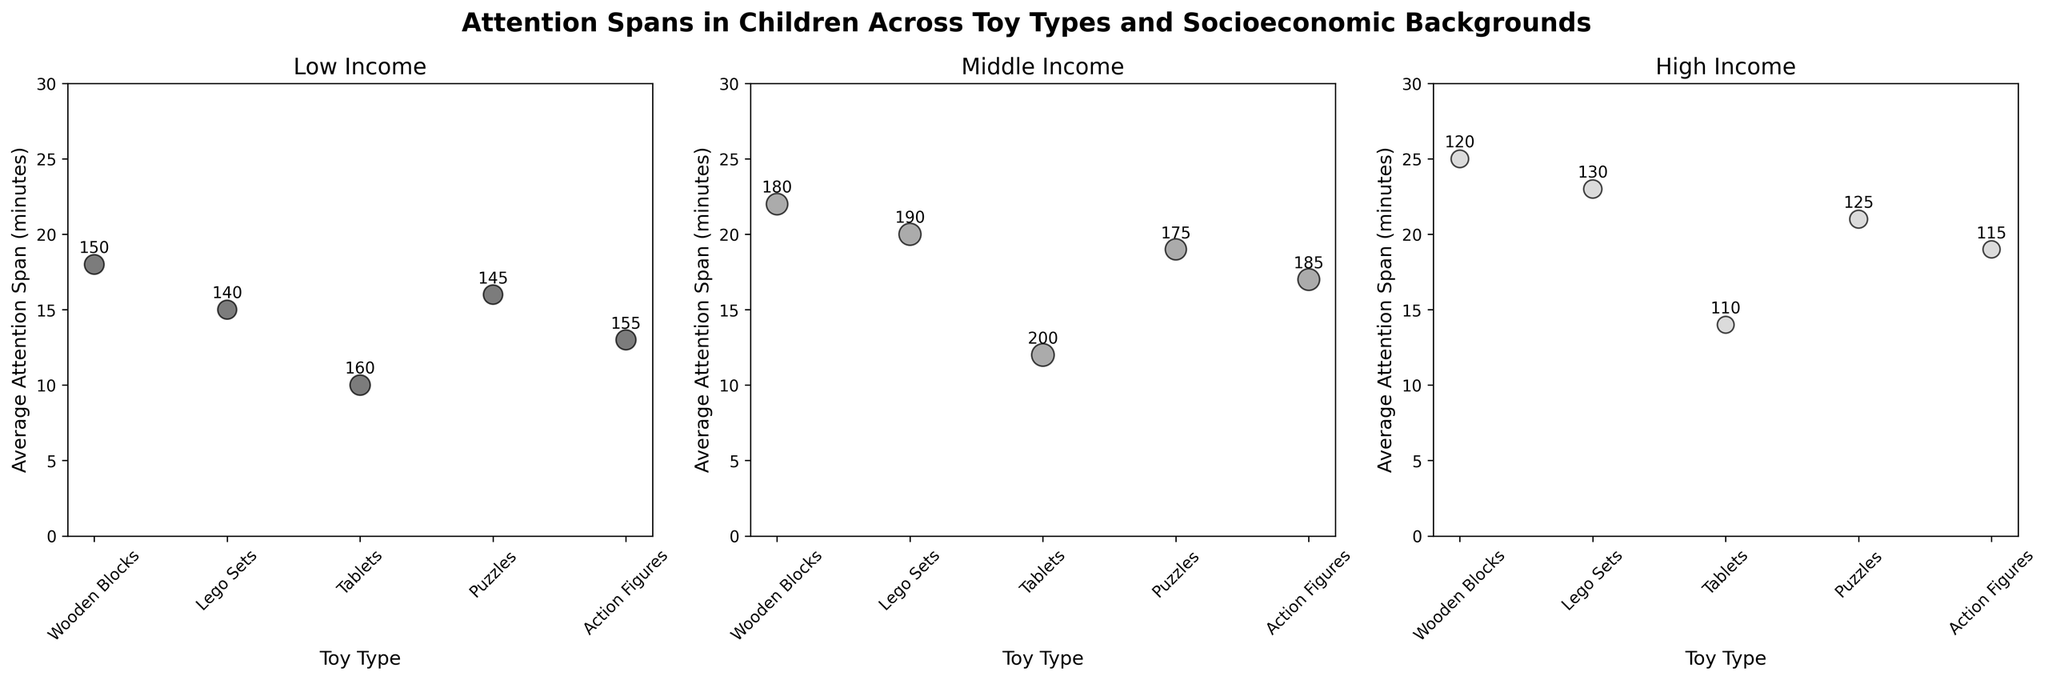What's the title of the figure? The title of the plot is indicated at the top of the figure, which sets the context for the analysis.
Answer: Attention Spans in Children Across Toy Types and Socioeconomic Backgrounds How many socioeconomic backgrounds are compared in the figure? The figure contains three subplots, each with a different title indicating the socioeconomic backgrounds being compared.
Answer: 3 Which socioeconomic background shows the highest average attention span for Wooden Blocks? By reviewing the y-axis values in each of the subplots, the highest average attention span for Wooden Blocks can be found in the subplot titled 'High Income'.
Answer: High Income Which toy type tends to have the lowest average attention span across all socioeconomic backgrounds? The toy type with the lowest average attention span would have the smallest values consistently across all the subplots. By comparing the y-axis values for each toy type, Tablets have the lowest values in all socioeconomic categories.
Answer: Tablets What is the sample size for children using Lego Sets in the Middle Income group? The sample size can be found in the annotations on the bubbles for the subplot titled 'Middle Income' for the specific 'Lego Sets' data point.
Answer: 190 Compare the average attention span of children using Puzzles in the Low Income group to children using Tablets in the same group. Which is higher? To determine which is higher, compare the y-axis values for Puzzles and Tablets in the 'Low Income' subplot. Puzzles have an average attention span of 16 minutes, while Tablets have 10 minutes.
Answer: Puzzles Across the High-Income subgroup, which two toy types show the closest average attention span? For the High-Income subplot, compare the y-axis values and look for the two toy types with the smallest difference in average attention spans, which are 'Puzzles' (21 minutes) and 'Action Figures' (19 minutes).
Answer: Puzzles and Action Figures How does the average attention span of children using Action Figures in the Low Income group compare to those in the Middle Income group? By comparing the y-axis values for Action Figures, Low Income shows 13 minutes, and Middle Income shows 17 minutes, indicating that the Middle Income group has a higher average attention span.
Answer: Middle Income Which plot shows the smallest range of average attention spans among toy types? The range can be determined by subtracting the smallest y-axis value from the largest in each subplot. The subplot for High Income has the smallest range from 14 (Tablets) to 25 (Wooden Blocks), which is 11 minutes.
Answer: High Income 